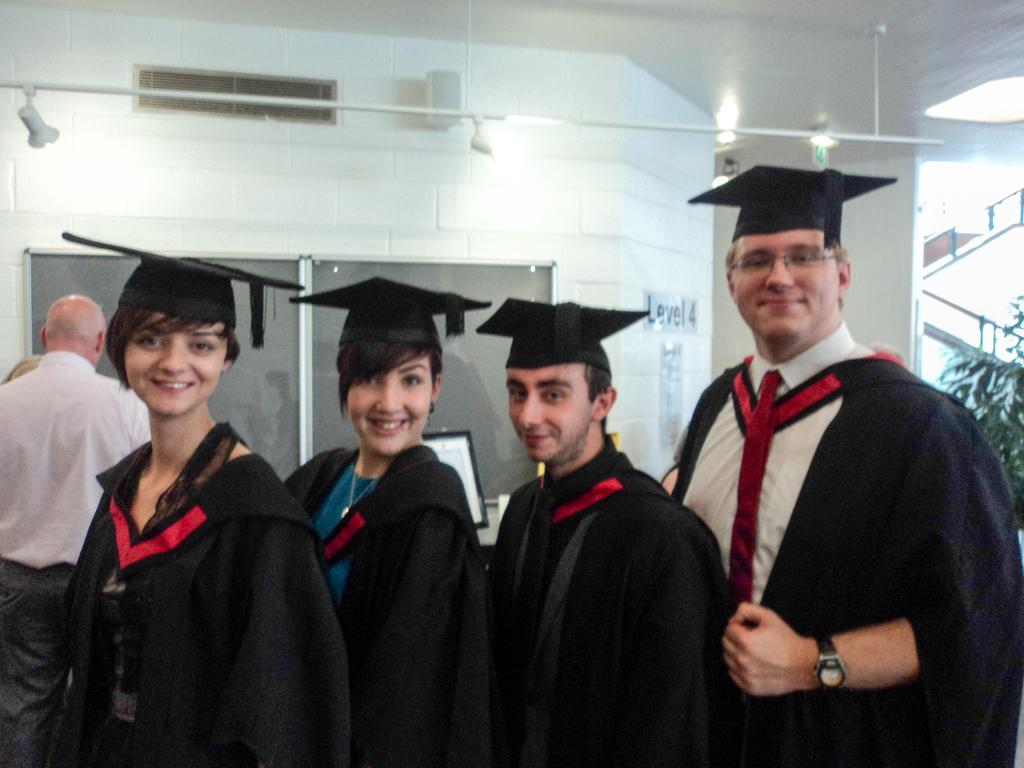How many people are present in the image? There are four people standing in the image. What is the facial expression of the people in the image? The people are smiling. What can be seen in the background of the image? There are lights, a monitor, and a plant in the background of the image. What type of wine is being served at the shop in the image? There is no wine or shop present in the image; it features four people standing and smiling with a background containing lights, a monitor, and a plant. 